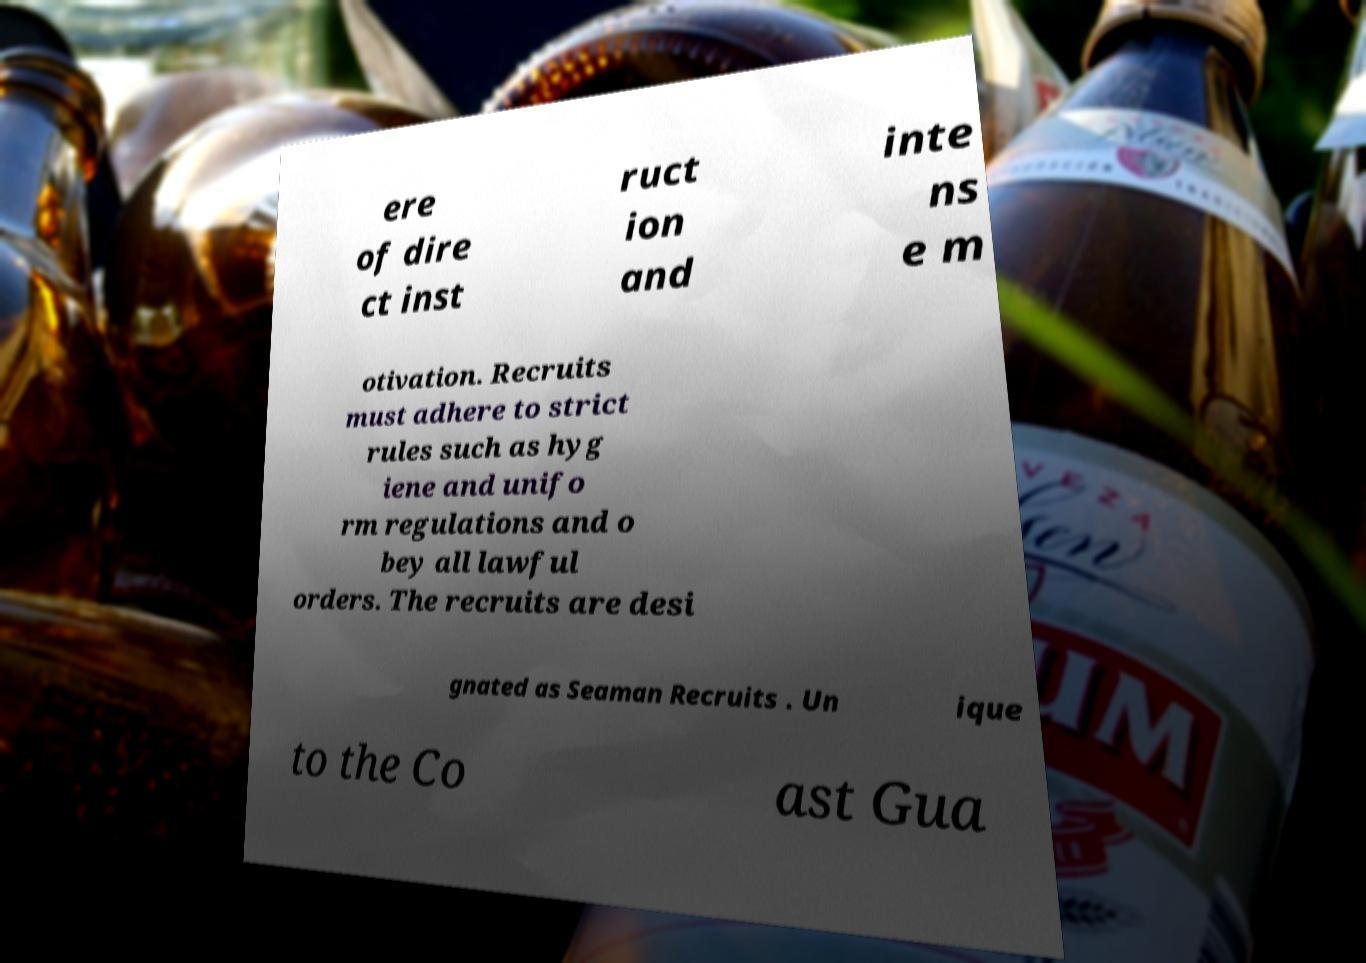Could you extract and type out the text from this image? ere of dire ct inst ruct ion and inte ns e m otivation. Recruits must adhere to strict rules such as hyg iene and unifo rm regulations and o bey all lawful orders. The recruits are desi gnated as Seaman Recruits . Un ique to the Co ast Gua 